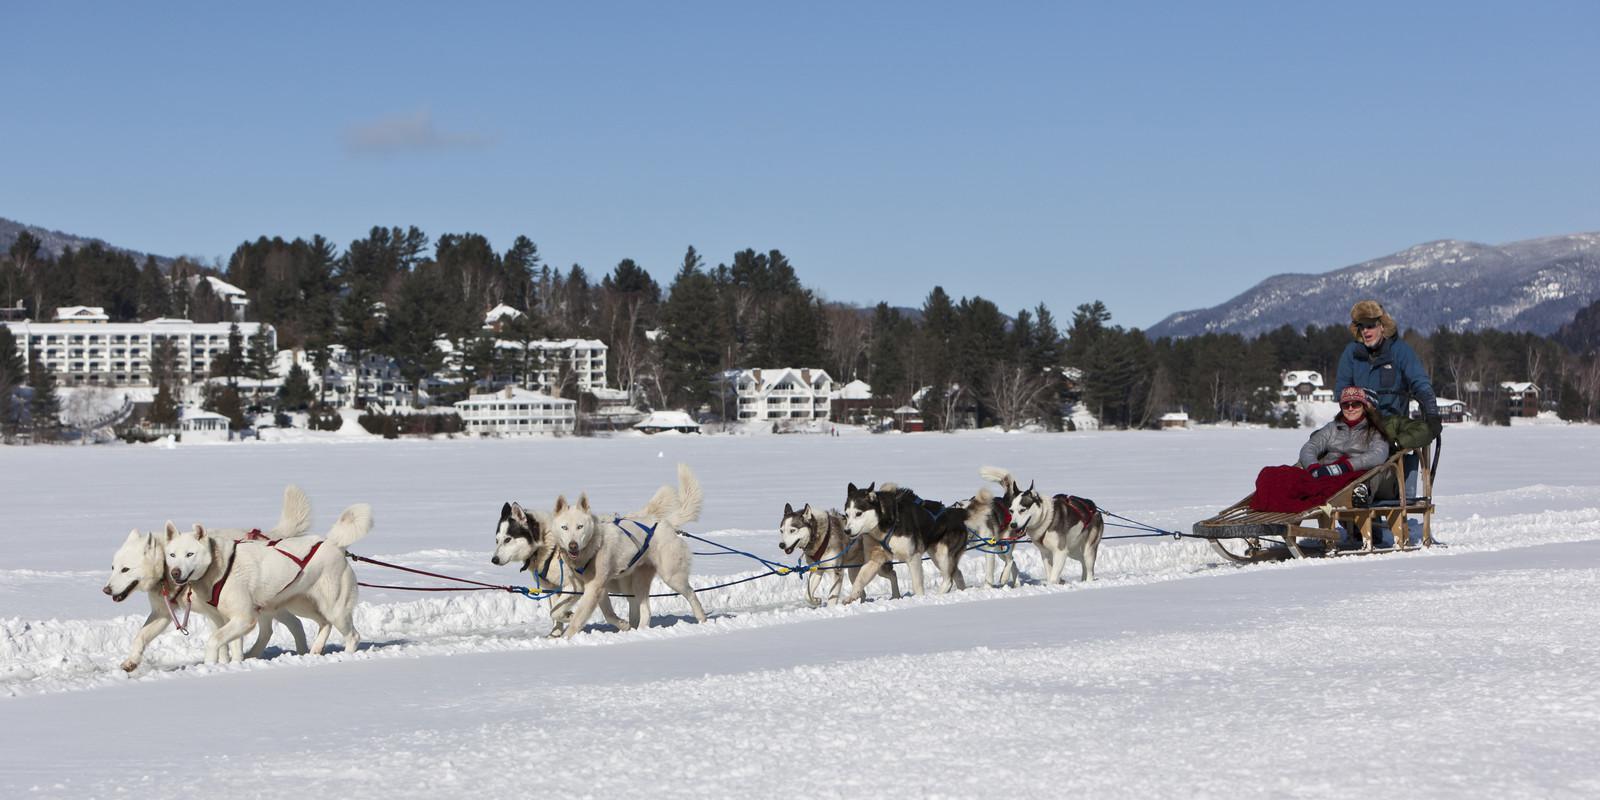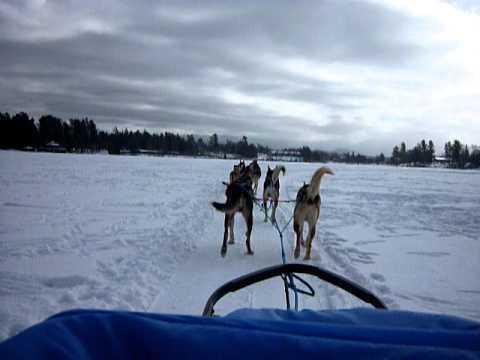The first image is the image on the left, the second image is the image on the right. Considering the images on both sides, is "There is a person in a red coat in the image on the left" valid? Answer yes or no. No. 